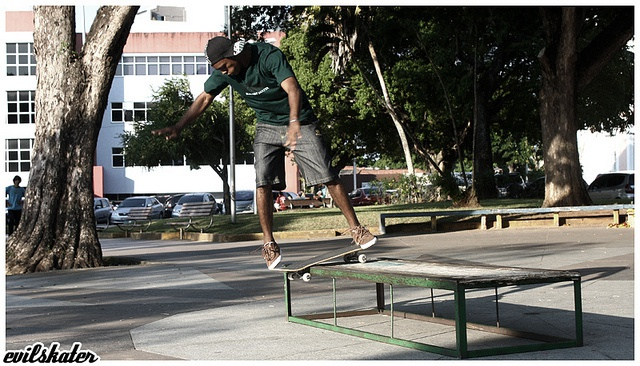Describe the objects in this image and their specific colors. I can see bench in white, black, darkgray, gray, and lightgray tones, people in white, black, gray, and darkgray tones, bench in white, black, lightgray, darkgray, and tan tones, skateboard in white, gray, black, darkgray, and ivory tones, and car in white, black, and purple tones in this image. 